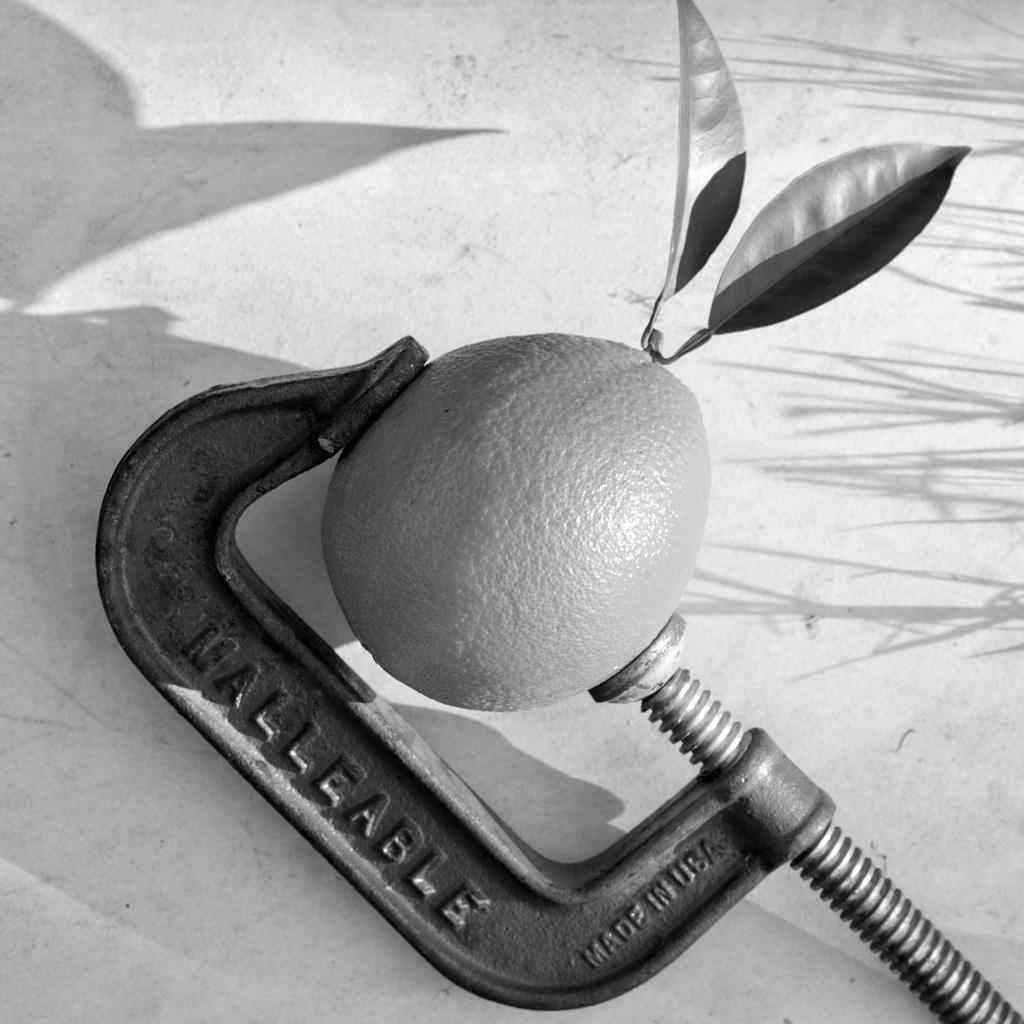<image>
Present a compact description of the photo's key features. An orange with two leafs coming from it's head is secured with a C clamp made by Malleable. 